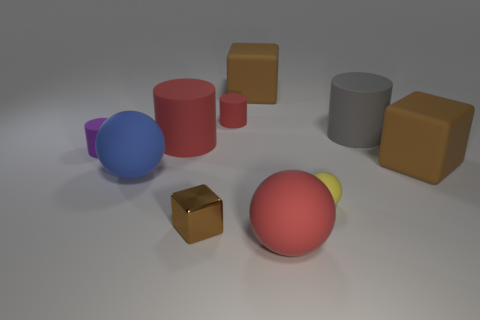Subtract all brown cubes. How many were subtracted if there are1brown cubes left? 2 Subtract all brown rubber blocks. How many blocks are left? 1 Subtract all brown spheres. How many red cylinders are left? 2 Subtract all cubes. How many objects are left? 7 Subtract all purple cylinders. How many cylinders are left? 3 Subtract all cyan metallic things. Subtract all large gray rubber cylinders. How many objects are left? 9 Add 9 small rubber balls. How many small rubber balls are left? 10 Add 5 yellow rubber objects. How many yellow rubber objects exist? 6 Subtract 0 yellow cubes. How many objects are left? 10 Subtract 3 cubes. How many cubes are left? 0 